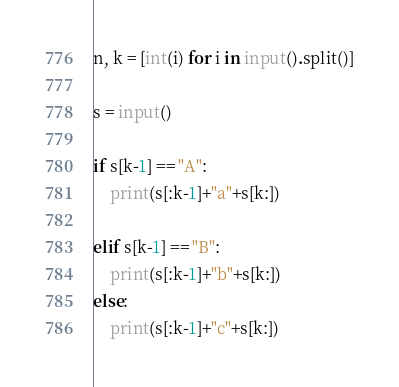<code> <loc_0><loc_0><loc_500><loc_500><_Python_>

n, k = [int(i) for i in input().split()]

s = input()

if s[k-1] == "A":
    print(s[:k-1]+"a"+s[k:])

elif s[k-1] == "B":
    print(s[:k-1]+"b"+s[k:])
else:
    print(s[:k-1]+"c"+s[k:])</code> 